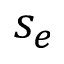Convert formula to latex. <formula><loc_0><loc_0><loc_500><loc_500>s _ { e }</formula> 